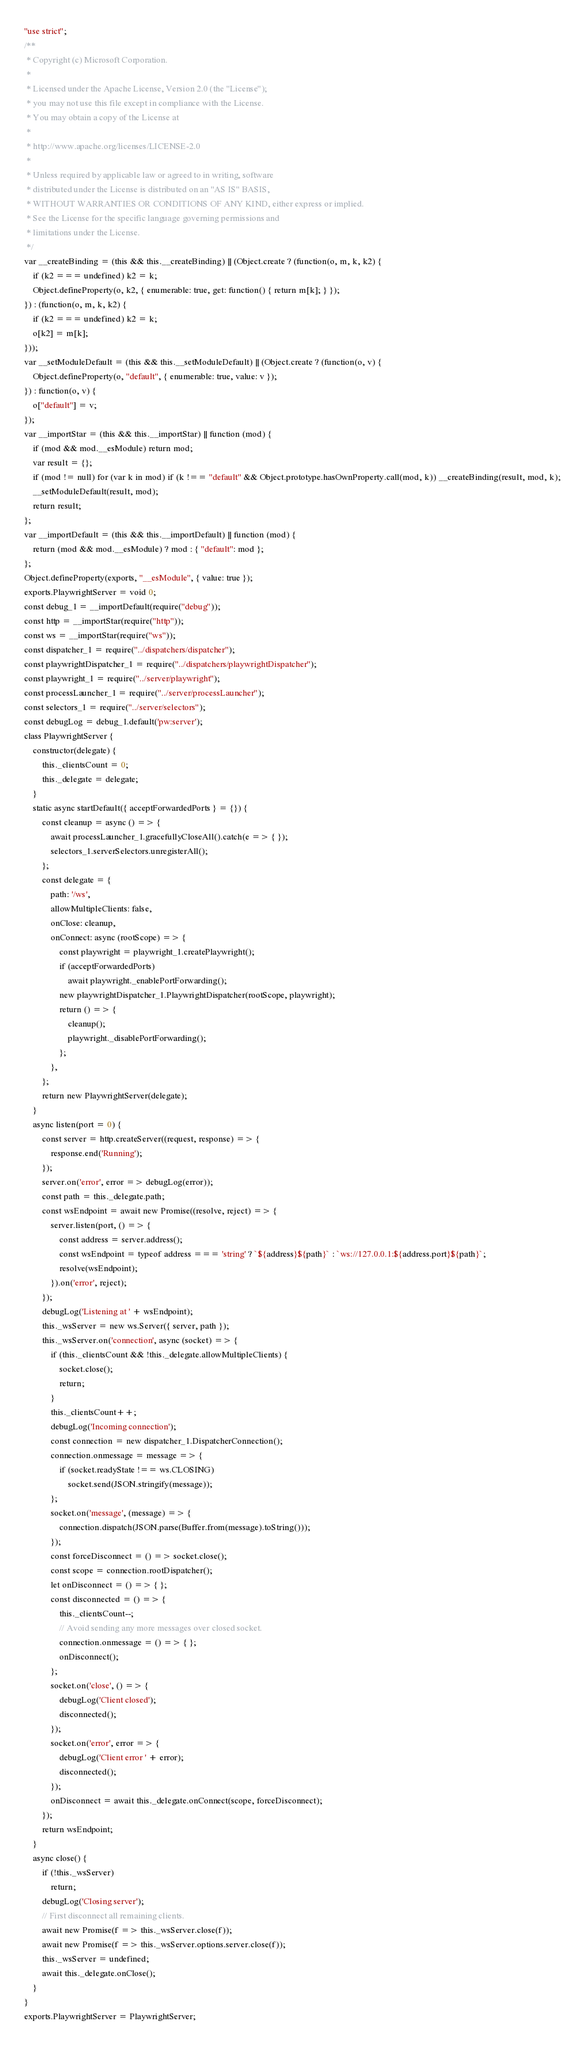<code> <loc_0><loc_0><loc_500><loc_500><_JavaScript_>"use strict";
/**
 * Copyright (c) Microsoft Corporation.
 *
 * Licensed under the Apache License, Version 2.0 (the "License");
 * you may not use this file except in compliance with the License.
 * You may obtain a copy of the License at
 *
 * http://www.apache.org/licenses/LICENSE-2.0
 *
 * Unless required by applicable law or agreed to in writing, software
 * distributed under the License is distributed on an "AS IS" BASIS,
 * WITHOUT WARRANTIES OR CONDITIONS OF ANY KIND, either express or implied.
 * See the License for the specific language governing permissions and
 * limitations under the License.
 */
var __createBinding = (this && this.__createBinding) || (Object.create ? (function(o, m, k, k2) {
    if (k2 === undefined) k2 = k;
    Object.defineProperty(o, k2, { enumerable: true, get: function() { return m[k]; } });
}) : (function(o, m, k, k2) {
    if (k2 === undefined) k2 = k;
    o[k2] = m[k];
}));
var __setModuleDefault = (this && this.__setModuleDefault) || (Object.create ? (function(o, v) {
    Object.defineProperty(o, "default", { enumerable: true, value: v });
}) : function(o, v) {
    o["default"] = v;
});
var __importStar = (this && this.__importStar) || function (mod) {
    if (mod && mod.__esModule) return mod;
    var result = {};
    if (mod != null) for (var k in mod) if (k !== "default" && Object.prototype.hasOwnProperty.call(mod, k)) __createBinding(result, mod, k);
    __setModuleDefault(result, mod);
    return result;
};
var __importDefault = (this && this.__importDefault) || function (mod) {
    return (mod && mod.__esModule) ? mod : { "default": mod };
};
Object.defineProperty(exports, "__esModule", { value: true });
exports.PlaywrightServer = void 0;
const debug_1 = __importDefault(require("debug"));
const http = __importStar(require("http"));
const ws = __importStar(require("ws"));
const dispatcher_1 = require("../dispatchers/dispatcher");
const playwrightDispatcher_1 = require("../dispatchers/playwrightDispatcher");
const playwright_1 = require("../server/playwright");
const processLauncher_1 = require("../server/processLauncher");
const selectors_1 = require("../server/selectors");
const debugLog = debug_1.default('pw:server');
class PlaywrightServer {
    constructor(delegate) {
        this._clientsCount = 0;
        this._delegate = delegate;
    }
    static async startDefault({ acceptForwardedPorts } = {}) {
        const cleanup = async () => {
            await processLauncher_1.gracefullyCloseAll().catch(e => { });
            selectors_1.serverSelectors.unregisterAll();
        };
        const delegate = {
            path: '/ws',
            allowMultipleClients: false,
            onClose: cleanup,
            onConnect: async (rootScope) => {
                const playwright = playwright_1.createPlaywright();
                if (acceptForwardedPorts)
                    await playwright._enablePortForwarding();
                new playwrightDispatcher_1.PlaywrightDispatcher(rootScope, playwright);
                return () => {
                    cleanup();
                    playwright._disablePortForwarding();
                };
            },
        };
        return new PlaywrightServer(delegate);
    }
    async listen(port = 0) {
        const server = http.createServer((request, response) => {
            response.end('Running');
        });
        server.on('error', error => debugLog(error));
        const path = this._delegate.path;
        const wsEndpoint = await new Promise((resolve, reject) => {
            server.listen(port, () => {
                const address = server.address();
                const wsEndpoint = typeof address === 'string' ? `${address}${path}` : `ws://127.0.0.1:${address.port}${path}`;
                resolve(wsEndpoint);
            }).on('error', reject);
        });
        debugLog('Listening at ' + wsEndpoint);
        this._wsServer = new ws.Server({ server, path });
        this._wsServer.on('connection', async (socket) => {
            if (this._clientsCount && !this._delegate.allowMultipleClients) {
                socket.close();
                return;
            }
            this._clientsCount++;
            debugLog('Incoming connection');
            const connection = new dispatcher_1.DispatcherConnection();
            connection.onmessage = message => {
                if (socket.readyState !== ws.CLOSING)
                    socket.send(JSON.stringify(message));
            };
            socket.on('message', (message) => {
                connection.dispatch(JSON.parse(Buffer.from(message).toString()));
            });
            const forceDisconnect = () => socket.close();
            const scope = connection.rootDispatcher();
            let onDisconnect = () => { };
            const disconnected = () => {
                this._clientsCount--;
                // Avoid sending any more messages over closed socket.
                connection.onmessage = () => { };
                onDisconnect();
            };
            socket.on('close', () => {
                debugLog('Client closed');
                disconnected();
            });
            socket.on('error', error => {
                debugLog('Client error ' + error);
                disconnected();
            });
            onDisconnect = await this._delegate.onConnect(scope, forceDisconnect);
        });
        return wsEndpoint;
    }
    async close() {
        if (!this._wsServer)
            return;
        debugLog('Closing server');
        // First disconnect all remaining clients.
        await new Promise(f => this._wsServer.close(f));
        await new Promise(f => this._wsServer.options.server.close(f));
        this._wsServer = undefined;
        await this._delegate.onClose();
    }
}
exports.PlaywrightServer = PlaywrightServer;</code> 